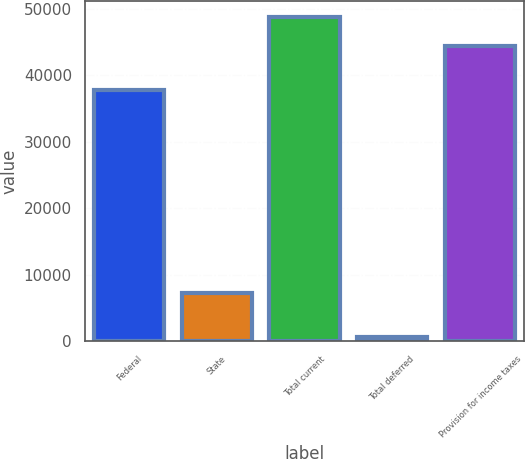<chart> <loc_0><loc_0><loc_500><loc_500><bar_chart><fcel>Federal<fcel>State<fcel>Total current<fcel>Total deferred<fcel>Provision for income taxes<nl><fcel>37770<fcel>7208<fcel>48748.7<fcel>661<fcel>44317<nl></chart> 